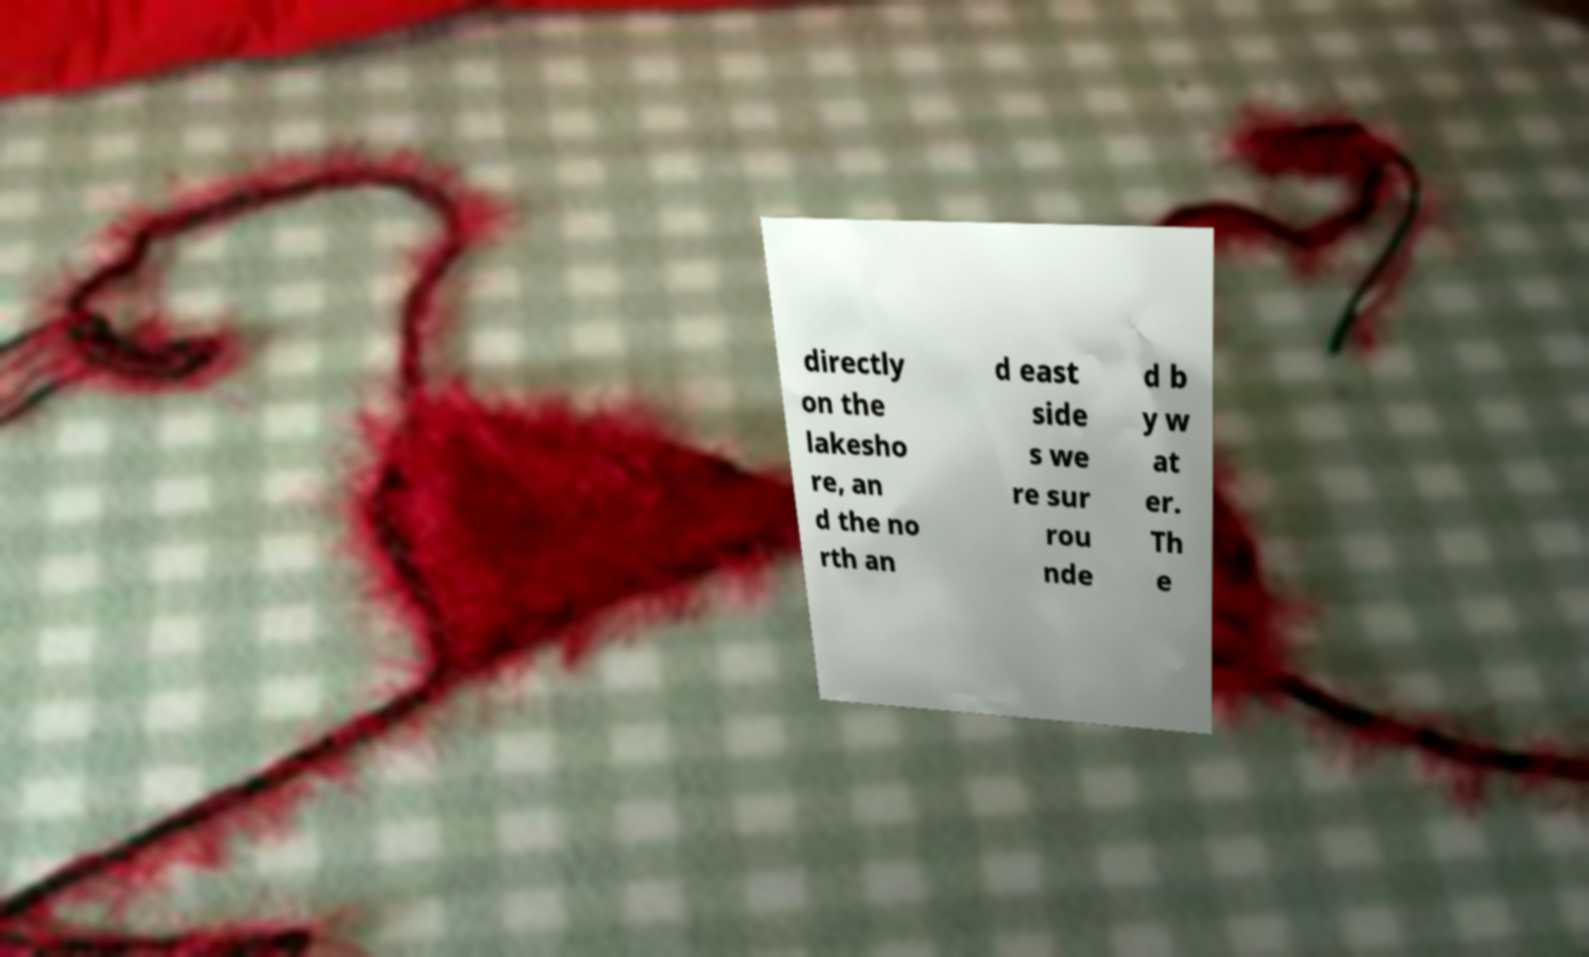Could you assist in decoding the text presented in this image and type it out clearly? directly on the lakesho re, an d the no rth an d east side s we re sur rou nde d b y w at er. Th e 